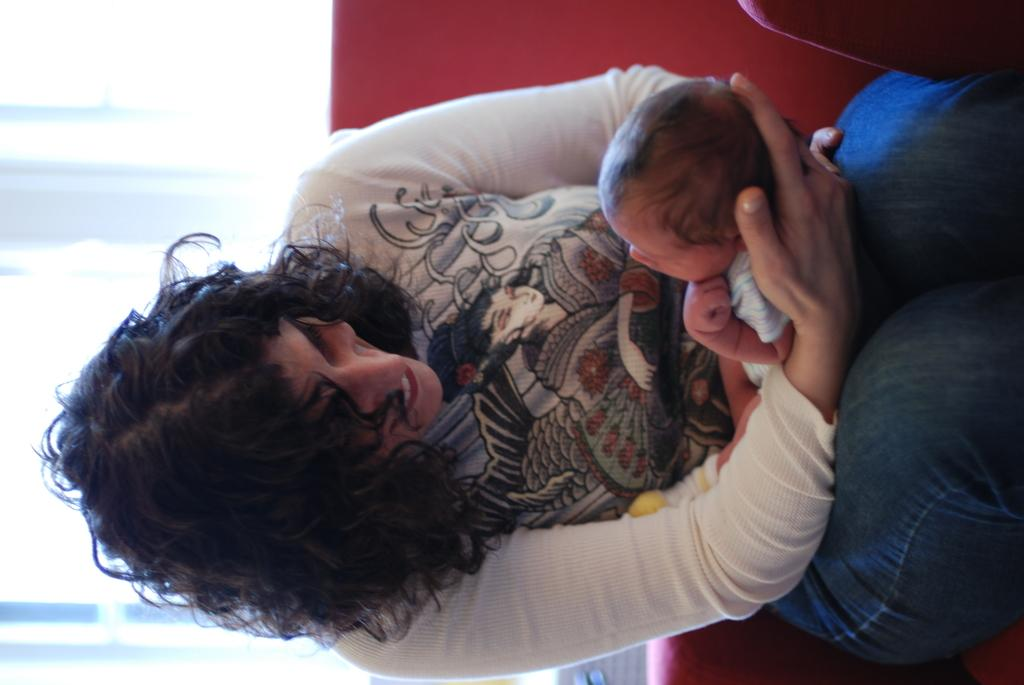Who is the main subject in the image? There is a lady in the image. What is the lady doing in the image? The lady is holding a baby. What can be seen behind the lady? The lady is sitting on a red color sofa. Is there a river flowing behind the lady in the image? No, there is no river visible in the image. 